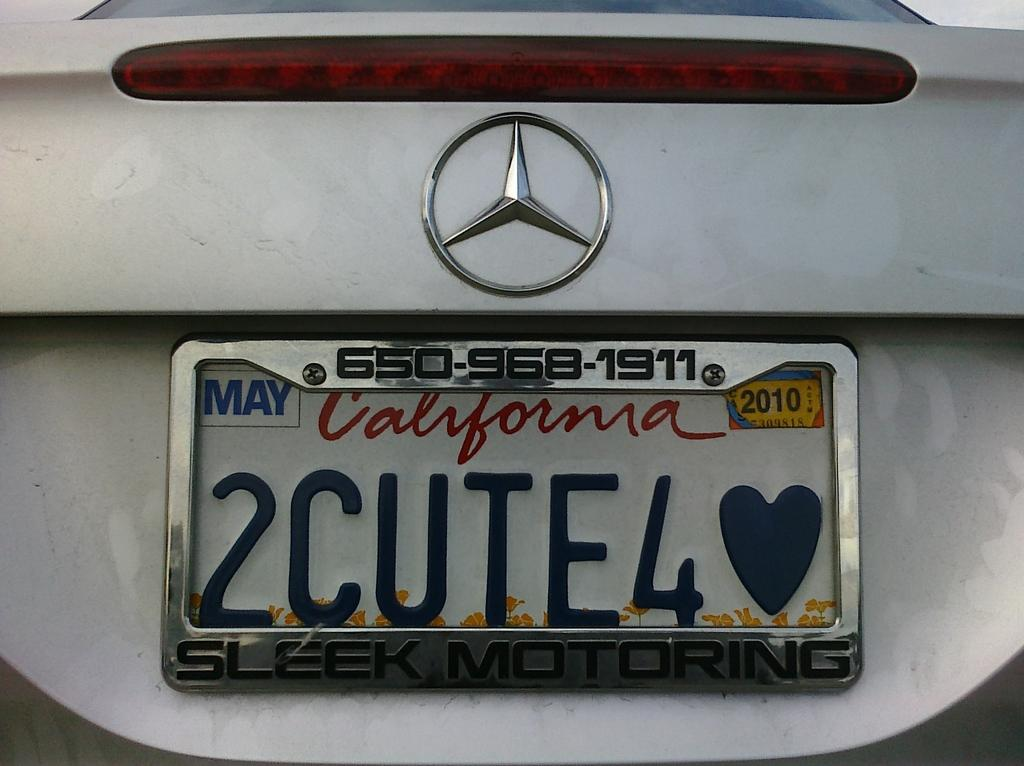<image>
Describe the image concisely. A light colored Mercedes has a number plate from California. 